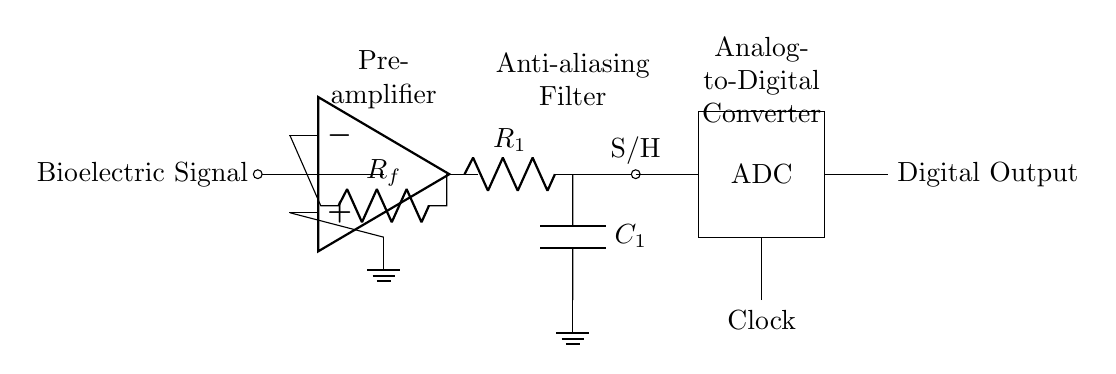What type of component is located at the input? The component at the input is a biological signal source, typically represented as a signal line leading into the circuit.
Answer: Bioelectric Signal What is the function of the op-amp in the circuit? The operational amplifier, or op-amp, amplifies the low-level bioelectric signal to a higher voltage suitable for further processing.
Answer: Amplifier What components make up the anti-aliasing filter? The anti-aliasing filter is composed of a resistor and a capacitor, which together smooth out the signal to prevent aliasing during sampling.
Answer: Resistor and Capacitor How many distinct blocks are in this circuit diagram? The circuit diagram contains three distinct functional blocks: the pre-amplifier, anti-aliasing filter, and analog-to-digital converter.
Answer: Three What is the purpose of the Sample and Hold section? The Sample and Hold section captures the amplified analog signal at a specific point in time, holding this value steady for the ADC to convert.
Answer: Holding the signal What role does the clock play in this ADC circuit? The clock provides timing signals that synchronize the sampling process of the analog-to-digital converter, ensuring accurate conversions based on timing.
Answer: Timing What is the final output of the circuit? The final output of the circuit is the digital representation of the processed bioelectric signal after conversion by the ADC.
Answer: Digital Output 